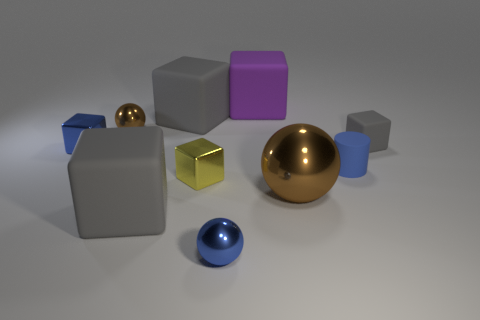There is another shiny object that is the same size as the purple thing; what is its shape?
Give a very brief answer. Sphere. There is a purple cube that is the same material as the small blue cylinder; what size is it?
Offer a terse response. Large. Do the tiny yellow shiny thing and the big purple object have the same shape?
Provide a succinct answer. Yes. The matte thing that is the same size as the cylinder is what color?
Provide a short and direct response. Gray. What is the size of the blue metallic object that is the same shape as the large brown thing?
Ensure brevity in your answer.  Small. What shape is the big gray object in front of the large brown thing?
Provide a succinct answer. Cube. There is a purple object; does it have the same shape as the tiny blue object that is in front of the yellow block?
Your answer should be very brief. No. Are there the same number of purple objects behind the yellow metal object and large gray objects that are in front of the big brown sphere?
Your response must be concise. Yes. The tiny object that is the same color as the large ball is what shape?
Provide a succinct answer. Sphere. Do the tiny cube on the right side of the tiny blue shiny ball and the big matte cube in front of the large brown ball have the same color?
Provide a short and direct response. Yes. 